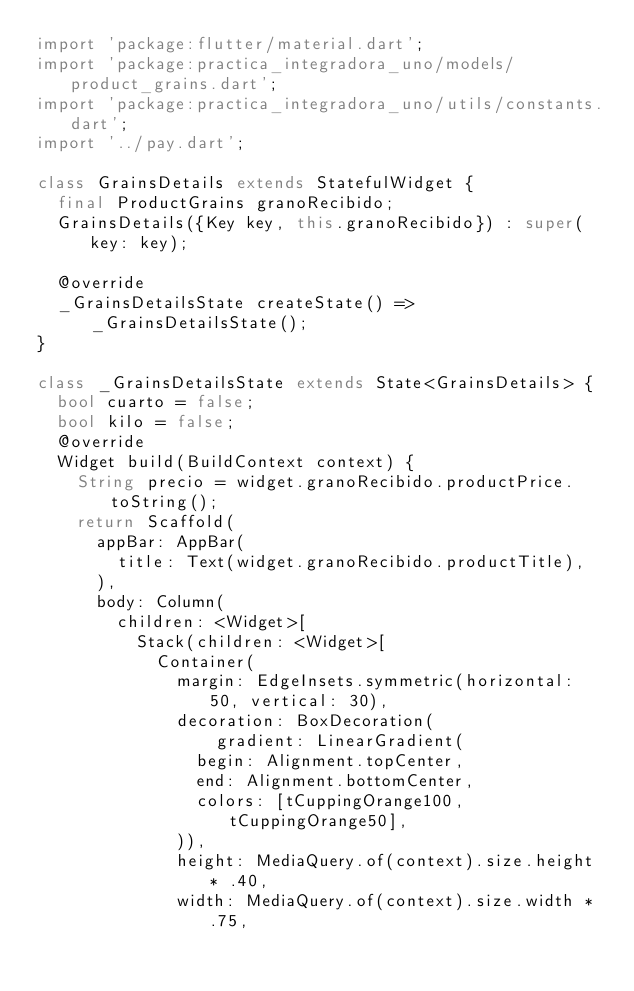Convert code to text. <code><loc_0><loc_0><loc_500><loc_500><_Dart_>import 'package:flutter/material.dart';
import 'package:practica_integradora_uno/models/product_grains.dart';
import 'package:practica_integradora_uno/utils/constants.dart';
import '../pay.dart';

class GrainsDetails extends StatefulWidget {
  final ProductGrains granoRecibido;
  GrainsDetails({Key key, this.granoRecibido}) : super(key: key);

  @override
  _GrainsDetailsState createState() => _GrainsDetailsState();
}

class _GrainsDetailsState extends State<GrainsDetails> {
  bool cuarto = false;
  bool kilo = false;
  @override
  Widget build(BuildContext context) {
    String precio = widget.granoRecibido.productPrice.toString();
    return Scaffold(
      appBar: AppBar(
        title: Text(widget.granoRecibido.productTitle),
      ),
      body: Column(
        children: <Widget>[
          Stack(children: <Widget>[
            Container(
              margin: EdgeInsets.symmetric(horizontal: 50, vertical: 30),
              decoration: BoxDecoration(
                  gradient: LinearGradient(
                begin: Alignment.topCenter,
                end: Alignment.bottomCenter,
                colors: [tCuppingOrange100, tCuppingOrange50],
              )),
              height: MediaQuery.of(context).size.height * .40,
              width: MediaQuery.of(context).size.width * .75,</code> 